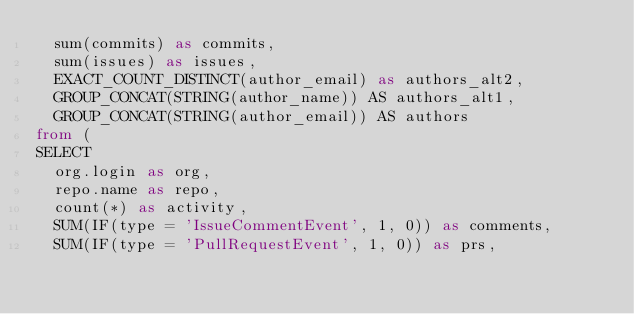Convert code to text. <code><loc_0><loc_0><loc_500><loc_500><_SQL_>  sum(commits) as commits,
  sum(issues) as issues,
  EXACT_COUNT_DISTINCT(author_email) as authors_alt2,
  GROUP_CONCAT(STRING(author_name)) AS authors_alt1,
  GROUP_CONCAT(STRING(author_email)) AS authors
from (
SELECT
  org.login as org,
  repo.name as repo,
  count(*) as activity,
  SUM(IF(type = 'IssueCommentEvent', 1, 0)) as comments,
  SUM(IF(type = 'PullRequestEvent', 1, 0)) as prs,</code> 